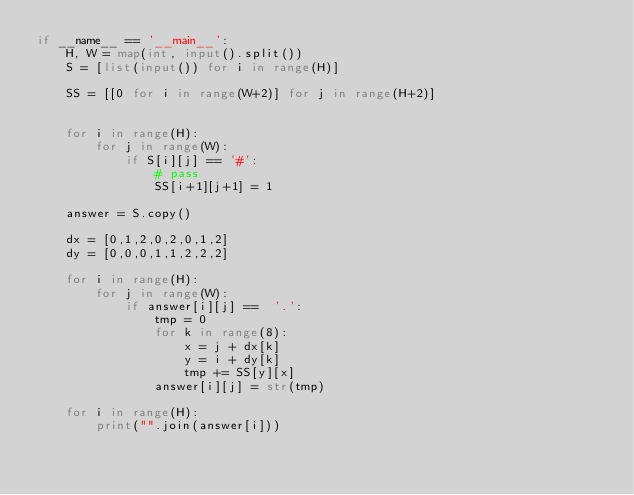Convert code to text. <code><loc_0><loc_0><loc_500><loc_500><_Python_>if __name__ == '__main__':
    H, W = map(int, input().split())
    S = [list(input()) for i in range(H)]

    SS = [[0 for i in range(W+2)] for j in range(H+2)]


    for i in range(H):
        for j in range(W):
            if S[i][j] == '#':
                # pass
                SS[i+1][j+1] = 1

    answer = S.copy()

    dx = [0,1,2,0,2,0,1,2]
    dy = [0,0,0,1,1,2,2,2]

    for i in range(H):
        for j in range(W):
            if answer[i][j] ==  '.':
                tmp = 0
                for k in range(8):
                    x = j + dx[k]
                    y = i + dy[k]
                    tmp += SS[y][x]
                answer[i][j] = str(tmp)

    for i in range(H):
        print("".join(answer[i]))
</code> 